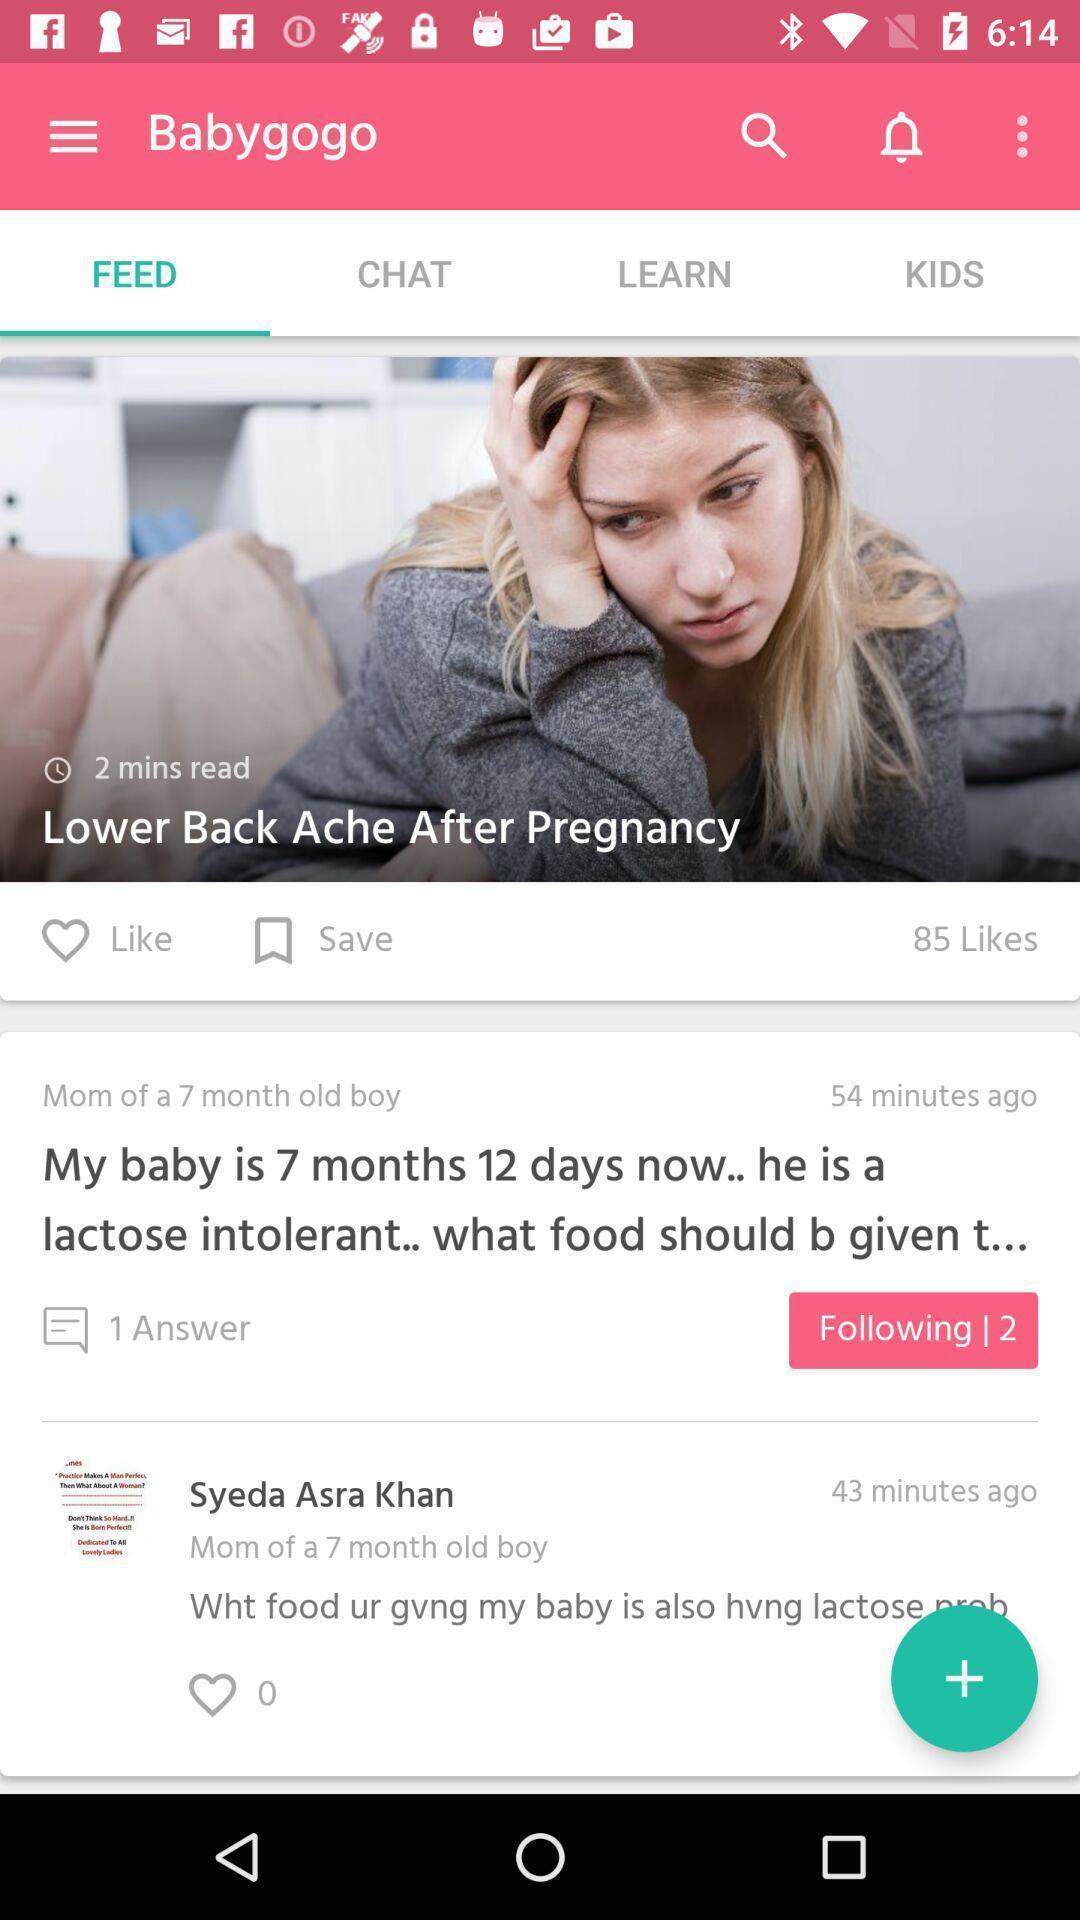Summarize the main components in this picture. Screen showing feed. 